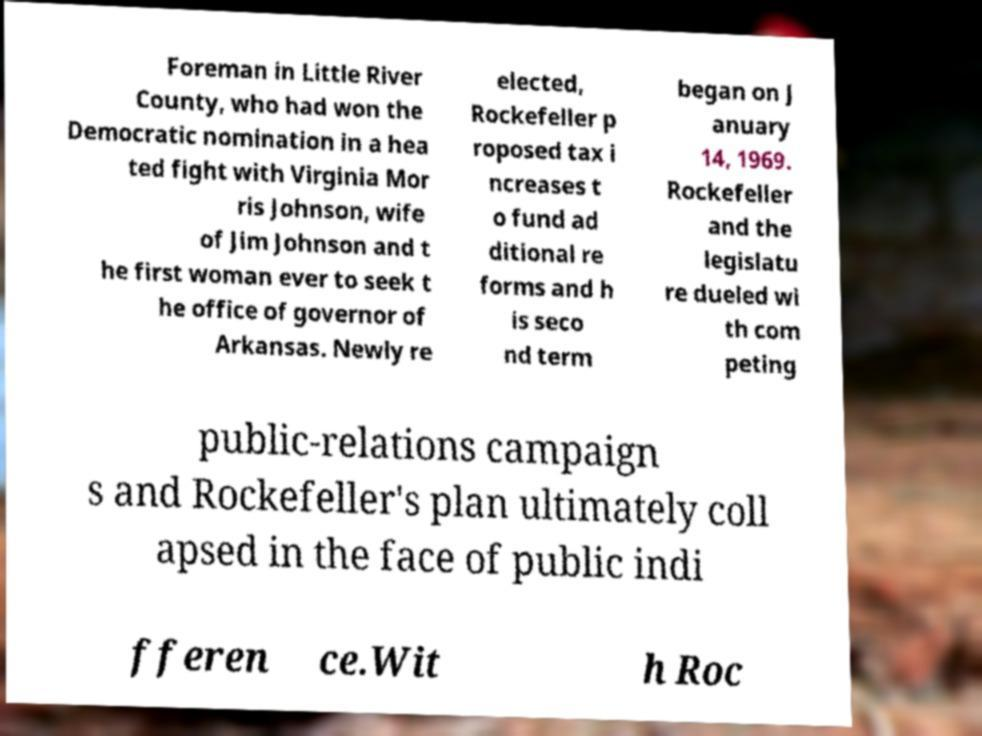There's text embedded in this image that I need extracted. Can you transcribe it verbatim? Foreman in Little River County, who had won the Democratic nomination in a hea ted fight with Virginia Mor ris Johnson, wife of Jim Johnson and t he first woman ever to seek t he office of governor of Arkansas. Newly re elected, Rockefeller p roposed tax i ncreases t o fund ad ditional re forms and h is seco nd term began on J anuary 14, 1969. Rockefeller and the legislatu re dueled wi th com peting public-relations campaign s and Rockefeller's plan ultimately coll apsed in the face of public indi fferen ce.Wit h Roc 